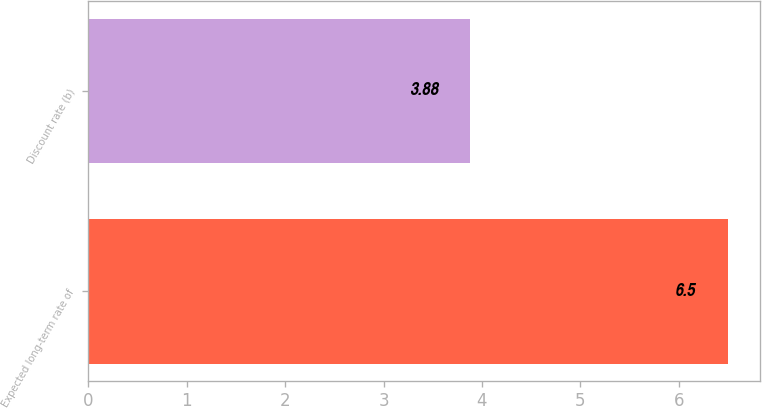Convert chart. <chart><loc_0><loc_0><loc_500><loc_500><bar_chart><fcel>Expected long-term rate of<fcel>Discount rate (b)<nl><fcel>6.5<fcel>3.88<nl></chart> 